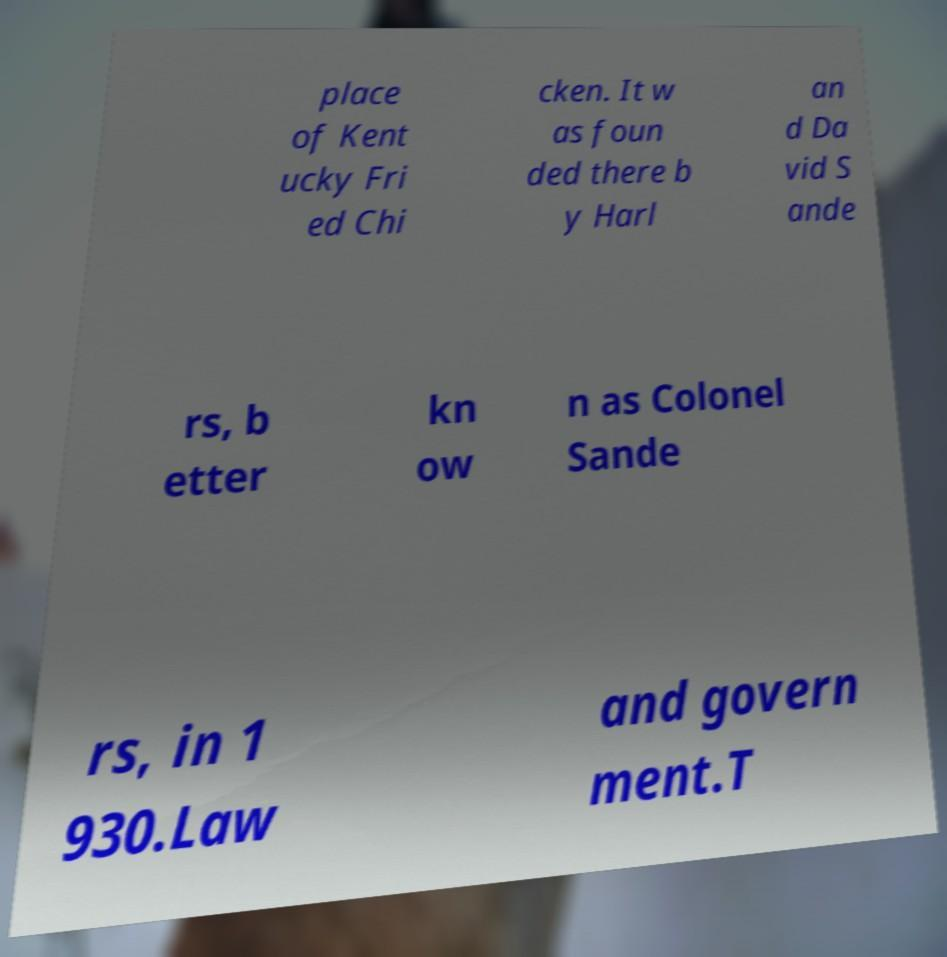Please identify and transcribe the text found in this image. place of Kent ucky Fri ed Chi cken. It w as foun ded there b y Harl an d Da vid S ande rs, b etter kn ow n as Colonel Sande rs, in 1 930.Law and govern ment.T 